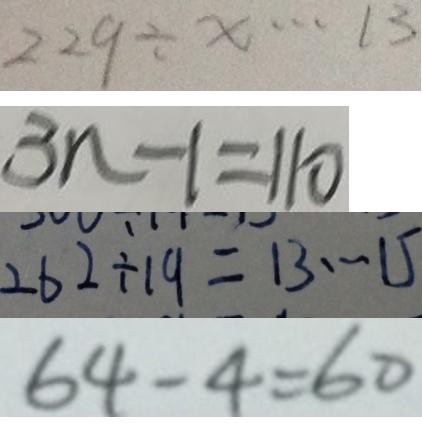Convert formula to latex. <formula><loc_0><loc_0><loc_500><loc_500>2 2 9 \div x \cdots 1 3 
 3 n - 1 = 1 1 0 
 2 6 2 \div 1 9 = 1 3 \cdots 1 5 
 6 4 - 4 = 6 0</formula> 